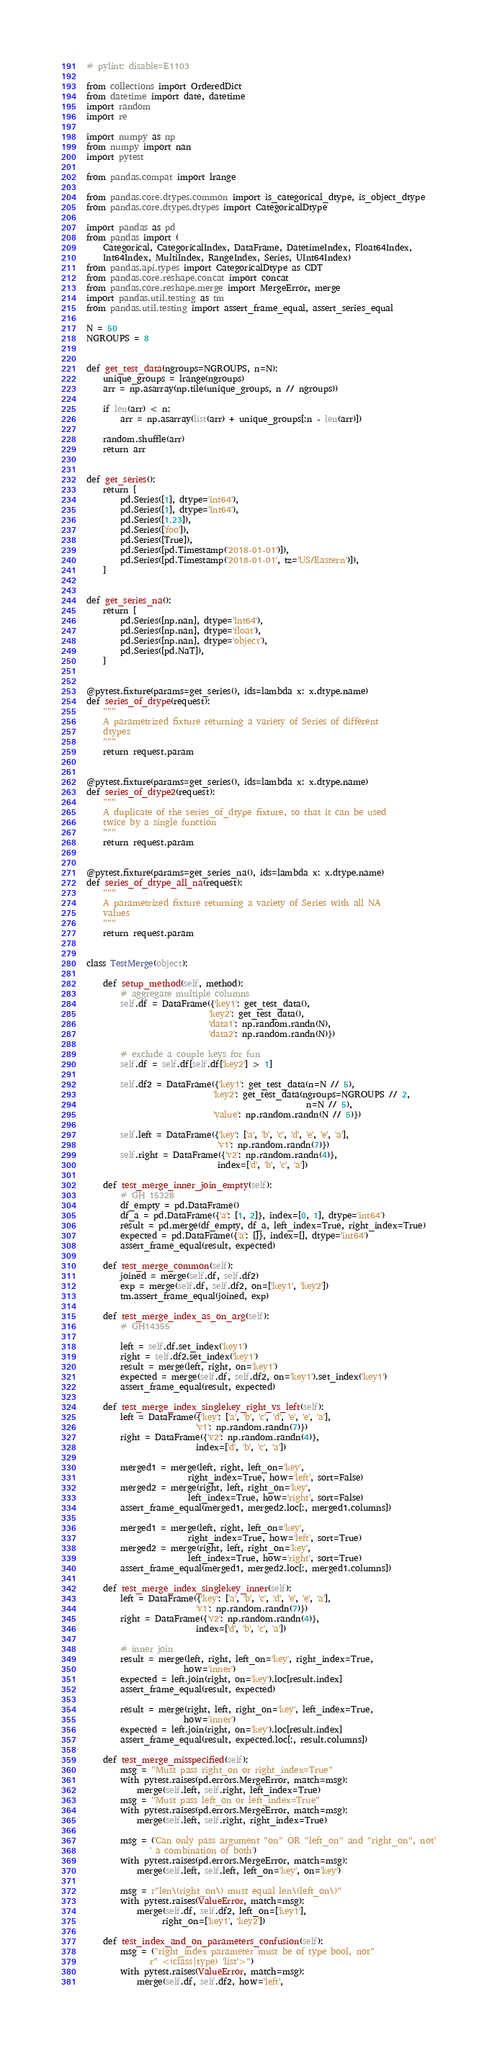<code> <loc_0><loc_0><loc_500><loc_500><_Python_># pylint: disable=E1103

from collections import OrderedDict
from datetime import date, datetime
import random
import re

import numpy as np
from numpy import nan
import pytest

from pandas.compat import lrange

from pandas.core.dtypes.common import is_categorical_dtype, is_object_dtype
from pandas.core.dtypes.dtypes import CategoricalDtype

import pandas as pd
from pandas import (
    Categorical, CategoricalIndex, DataFrame, DatetimeIndex, Float64Index,
    Int64Index, MultiIndex, RangeIndex, Series, UInt64Index)
from pandas.api.types import CategoricalDtype as CDT
from pandas.core.reshape.concat import concat
from pandas.core.reshape.merge import MergeError, merge
import pandas.util.testing as tm
from pandas.util.testing import assert_frame_equal, assert_series_equal

N = 50
NGROUPS = 8


def get_test_data(ngroups=NGROUPS, n=N):
    unique_groups = lrange(ngroups)
    arr = np.asarray(np.tile(unique_groups, n // ngroups))

    if len(arr) < n:
        arr = np.asarray(list(arr) + unique_groups[:n - len(arr)])

    random.shuffle(arr)
    return arr


def get_series():
    return [
        pd.Series([1], dtype='int64'),
        pd.Series([1], dtype='Int64'),
        pd.Series([1.23]),
        pd.Series(['foo']),
        pd.Series([True]),
        pd.Series([pd.Timestamp('2018-01-01')]),
        pd.Series([pd.Timestamp('2018-01-01', tz='US/Eastern')]),
    ]


def get_series_na():
    return [
        pd.Series([np.nan], dtype='Int64'),
        pd.Series([np.nan], dtype='float'),
        pd.Series([np.nan], dtype='object'),
        pd.Series([pd.NaT]),
    ]


@pytest.fixture(params=get_series(), ids=lambda x: x.dtype.name)
def series_of_dtype(request):
    """
    A parametrized fixture returning a variety of Series of different
    dtypes
    """
    return request.param


@pytest.fixture(params=get_series(), ids=lambda x: x.dtype.name)
def series_of_dtype2(request):
    """
    A duplicate of the series_of_dtype fixture, so that it can be used
    twice by a single function
    """
    return request.param


@pytest.fixture(params=get_series_na(), ids=lambda x: x.dtype.name)
def series_of_dtype_all_na(request):
    """
    A parametrized fixture returning a variety of Series with all NA
    values
    """
    return request.param


class TestMerge(object):

    def setup_method(self, method):
        # aggregate multiple columns
        self.df = DataFrame({'key1': get_test_data(),
                             'key2': get_test_data(),
                             'data1': np.random.randn(N),
                             'data2': np.random.randn(N)})

        # exclude a couple keys for fun
        self.df = self.df[self.df['key2'] > 1]

        self.df2 = DataFrame({'key1': get_test_data(n=N // 5),
                              'key2': get_test_data(ngroups=NGROUPS // 2,
                                                    n=N // 5),
                              'value': np.random.randn(N // 5)})

        self.left = DataFrame({'key': ['a', 'b', 'c', 'd', 'e', 'e', 'a'],
                               'v1': np.random.randn(7)})
        self.right = DataFrame({'v2': np.random.randn(4)},
                               index=['d', 'b', 'c', 'a'])

    def test_merge_inner_join_empty(self):
        # GH 15328
        df_empty = pd.DataFrame()
        df_a = pd.DataFrame({'a': [1, 2]}, index=[0, 1], dtype='int64')
        result = pd.merge(df_empty, df_a, left_index=True, right_index=True)
        expected = pd.DataFrame({'a': []}, index=[], dtype='int64')
        assert_frame_equal(result, expected)

    def test_merge_common(self):
        joined = merge(self.df, self.df2)
        exp = merge(self.df, self.df2, on=['key1', 'key2'])
        tm.assert_frame_equal(joined, exp)

    def test_merge_index_as_on_arg(self):
        # GH14355

        left = self.df.set_index('key1')
        right = self.df2.set_index('key1')
        result = merge(left, right, on='key1')
        expected = merge(self.df, self.df2, on='key1').set_index('key1')
        assert_frame_equal(result, expected)

    def test_merge_index_singlekey_right_vs_left(self):
        left = DataFrame({'key': ['a', 'b', 'c', 'd', 'e', 'e', 'a'],
                          'v1': np.random.randn(7)})
        right = DataFrame({'v2': np.random.randn(4)},
                          index=['d', 'b', 'c', 'a'])

        merged1 = merge(left, right, left_on='key',
                        right_index=True, how='left', sort=False)
        merged2 = merge(right, left, right_on='key',
                        left_index=True, how='right', sort=False)
        assert_frame_equal(merged1, merged2.loc[:, merged1.columns])

        merged1 = merge(left, right, left_on='key',
                        right_index=True, how='left', sort=True)
        merged2 = merge(right, left, right_on='key',
                        left_index=True, how='right', sort=True)
        assert_frame_equal(merged1, merged2.loc[:, merged1.columns])

    def test_merge_index_singlekey_inner(self):
        left = DataFrame({'key': ['a', 'b', 'c', 'd', 'e', 'e', 'a'],
                          'v1': np.random.randn(7)})
        right = DataFrame({'v2': np.random.randn(4)},
                          index=['d', 'b', 'c', 'a'])

        # inner join
        result = merge(left, right, left_on='key', right_index=True,
                       how='inner')
        expected = left.join(right, on='key').loc[result.index]
        assert_frame_equal(result, expected)

        result = merge(right, left, right_on='key', left_index=True,
                       how='inner')
        expected = left.join(right, on='key').loc[result.index]
        assert_frame_equal(result, expected.loc[:, result.columns])

    def test_merge_misspecified(self):
        msg = "Must pass right_on or right_index=True"
        with pytest.raises(pd.errors.MergeError, match=msg):
            merge(self.left, self.right, left_index=True)
        msg = "Must pass left_on or left_index=True"
        with pytest.raises(pd.errors.MergeError, match=msg):
            merge(self.left, self.right, right_index=True)

        msg = ('Can only pass argument "on" OR "left_on" and "right_on", not'
               ' a combination of both')
        with pytest.raises(pd.errors.MergeError, match=msg):
            merge(self.left, self.left, left_on='key', on='key')

        msg = r"len\(right_on\) must equal len\(left_on\)"
        with pytest.raises(ValueError, match=msg):
            merge(self.df, self.df2, left_on=['key1'],
                  right_on=['key1', 'key2'])

    def test_index_and_on_parameters_confusion(self):
        msg = ("right_index parameter must be of type bool, not"
               r" <(class|type) 'list'>")
        with pytest.raises(ValueError, match=msg):
            merge(self.df, self.df2, how='left',</code> 